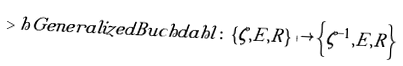<formula> <loc_0><loc_0><loc_500><loc_500>> h { G e n e r a l i z e d B u c h d a h l } \colon \left \{ \zeta , E , R \right \} \mapsto \left \{ \zeta ^ { - 1 } , E , R \right \}</formula> 